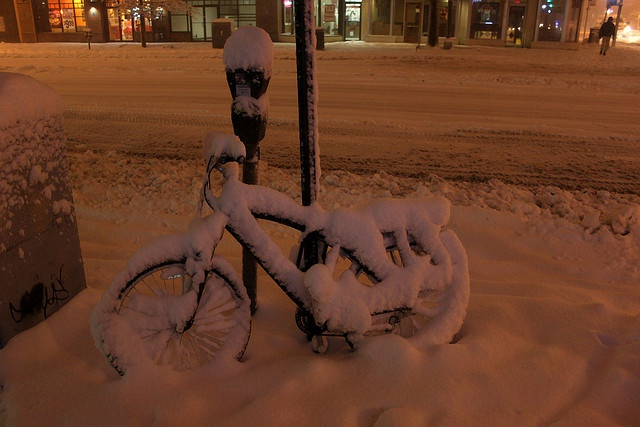Describe the objects in this image and their specific colors. I can see bicycle in maroon, brown, and black tones, parking meter in maroon, black, and brown tones, and people in maroon, black, and brown tones in this image. 